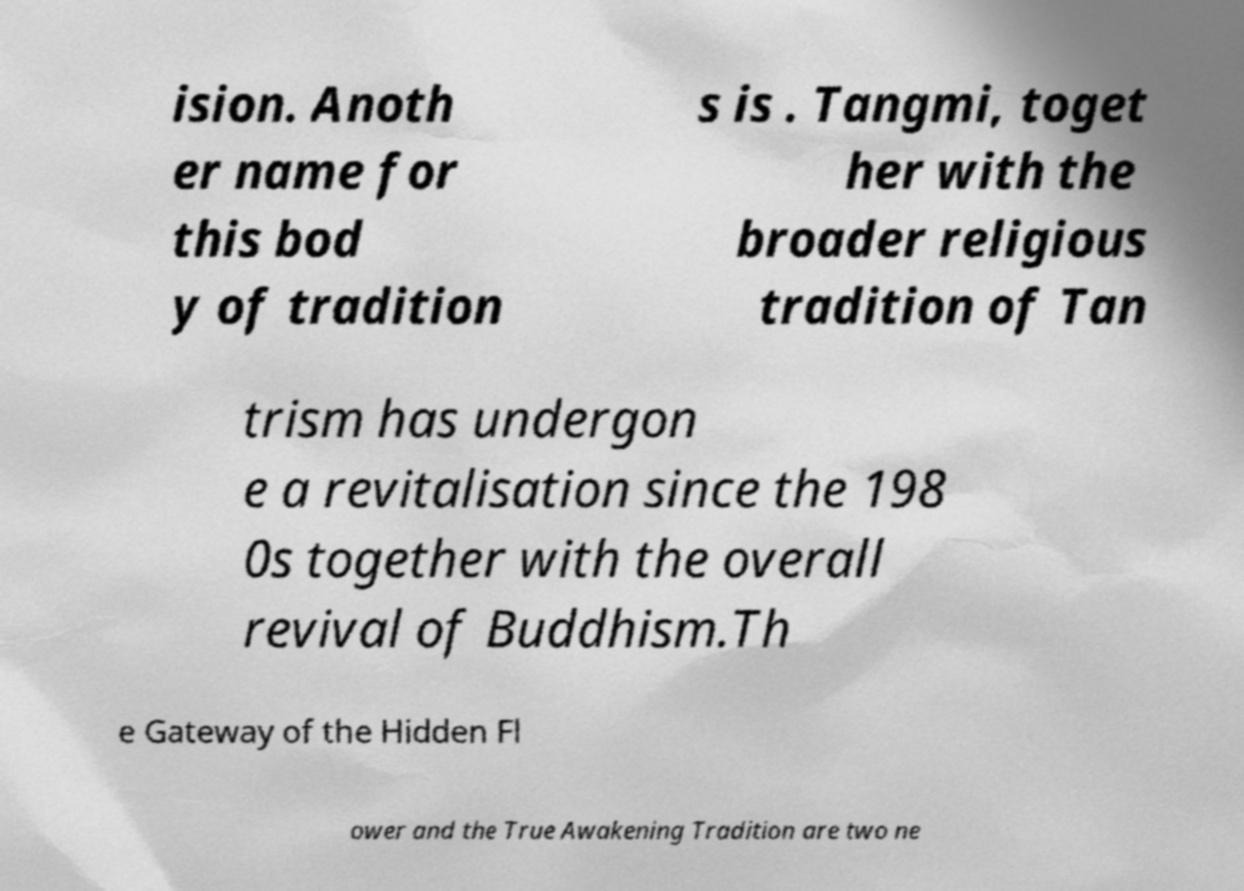Can you accurately transcribe the text from the provided image for me? ision. Anoth er name for this bod y of tradition s is . Tangmi, toget her with the broader religious tradition of Tan trism has undergon e a revitalisation since the 198 0s together with the overall revival of Buddhism.Th e Gateway of the Hidden Fl ower and the True Awakening Tradition are two ne 